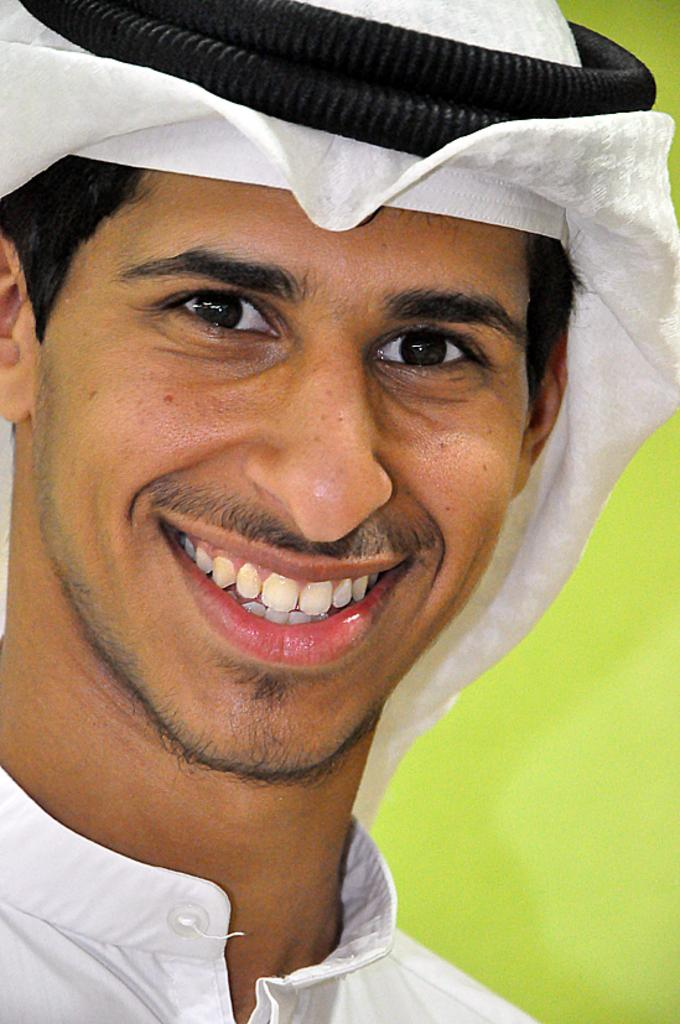What is present in the image? There is a person in the image. How is the person's facial expression? The person has a smile on their face. What can be seen behind the person? There is a wall visible behind the person. What type of pencil is the person holding in the image? There is no pencil present in the image. 